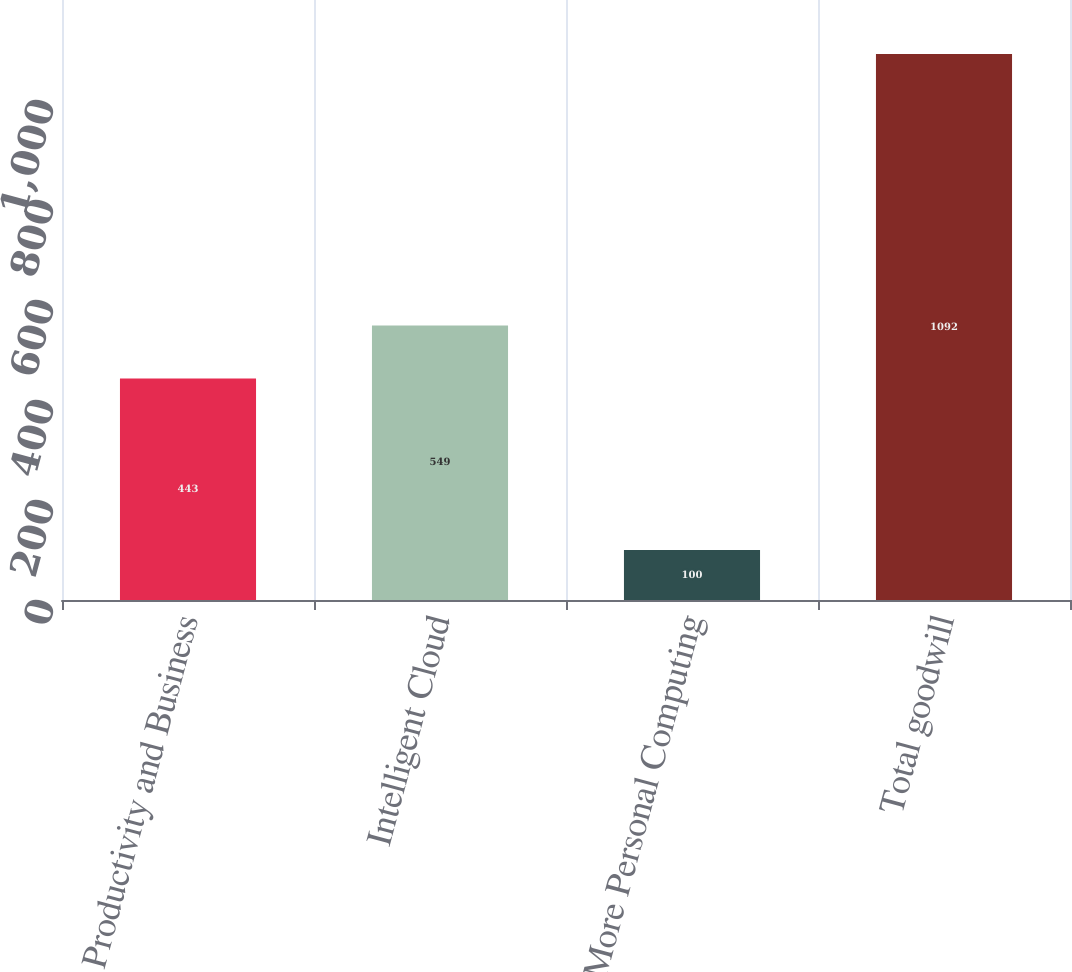Convert chart. <chart><loc_0><loc_0><loc_500><loc_500><bar_chart><fcel>Productivity and Business<fcel>Intelligent Cloud<fcel>More Personal Computing<fcel>Total goodwill<nl><fcel>443<fcel>549<fcel>100<fcel>1092<nl></chart> 